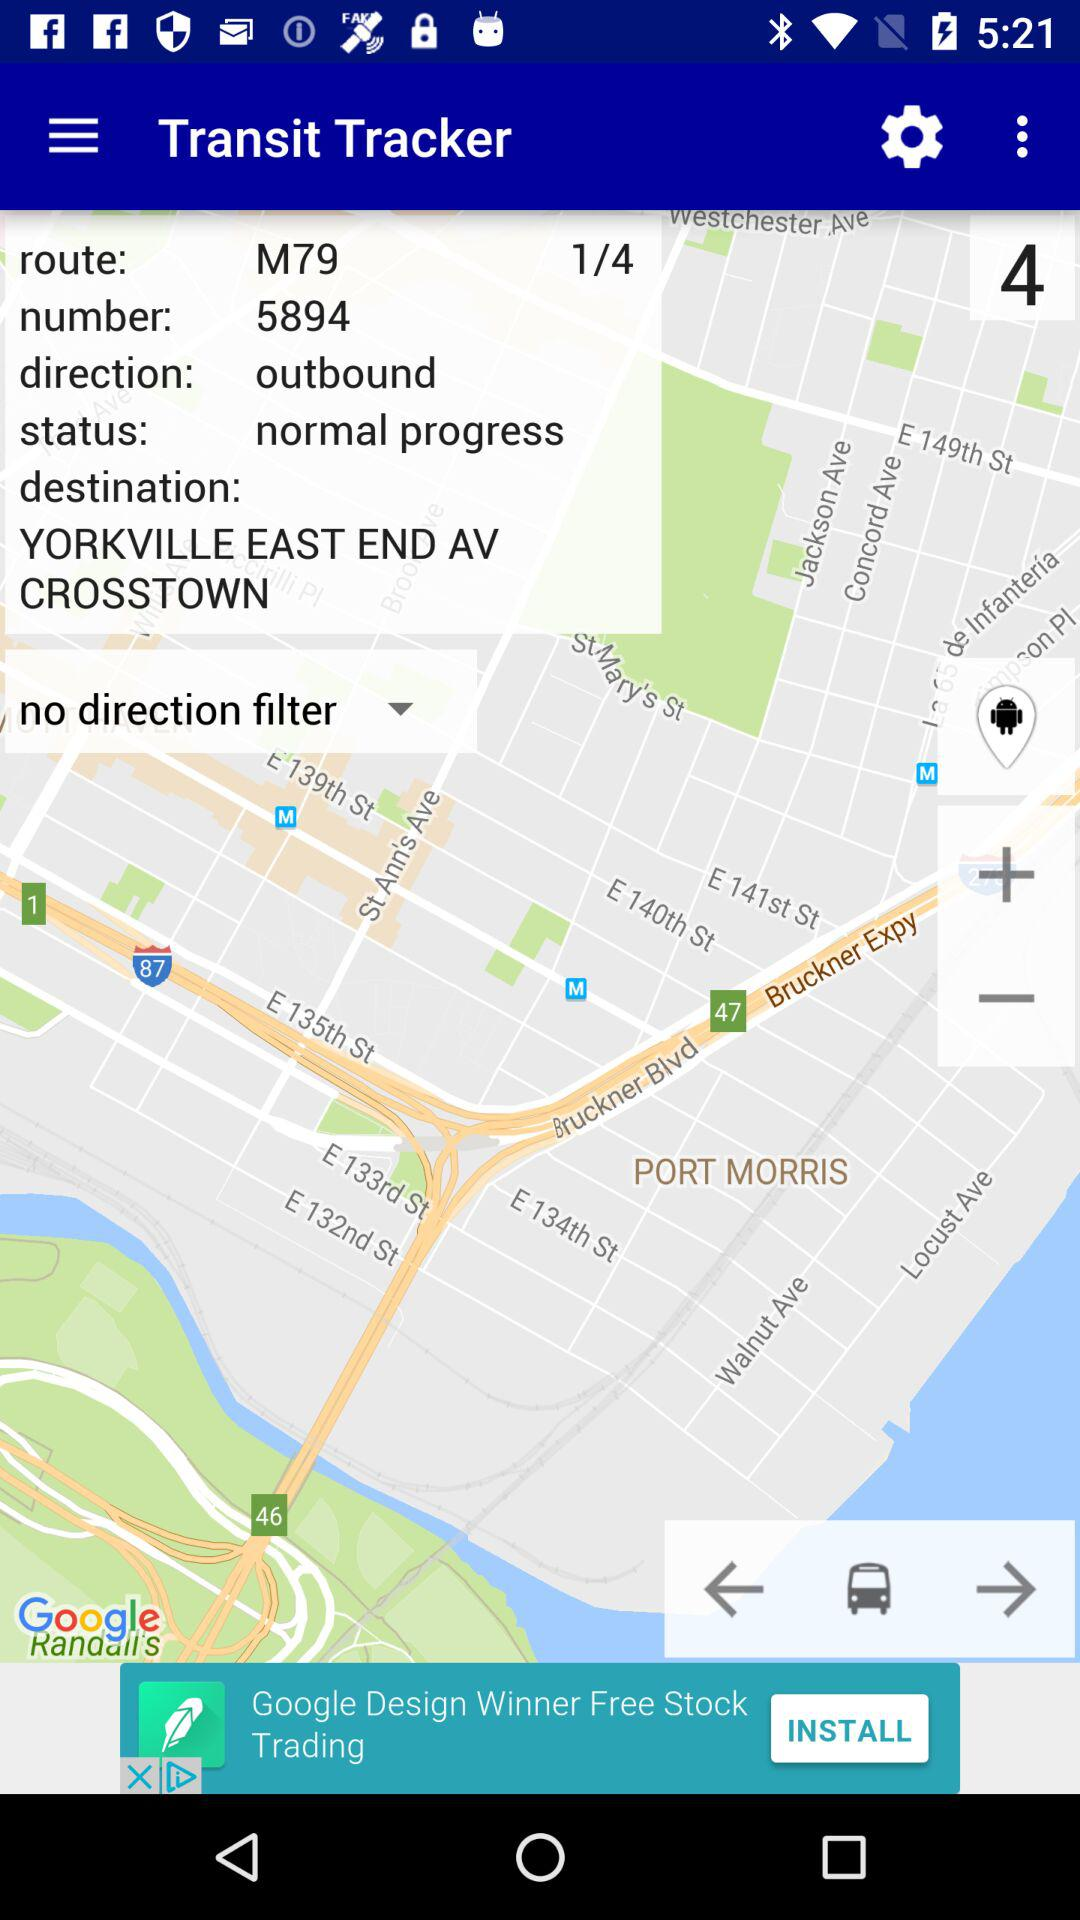Which route is given? The given route is M79. 